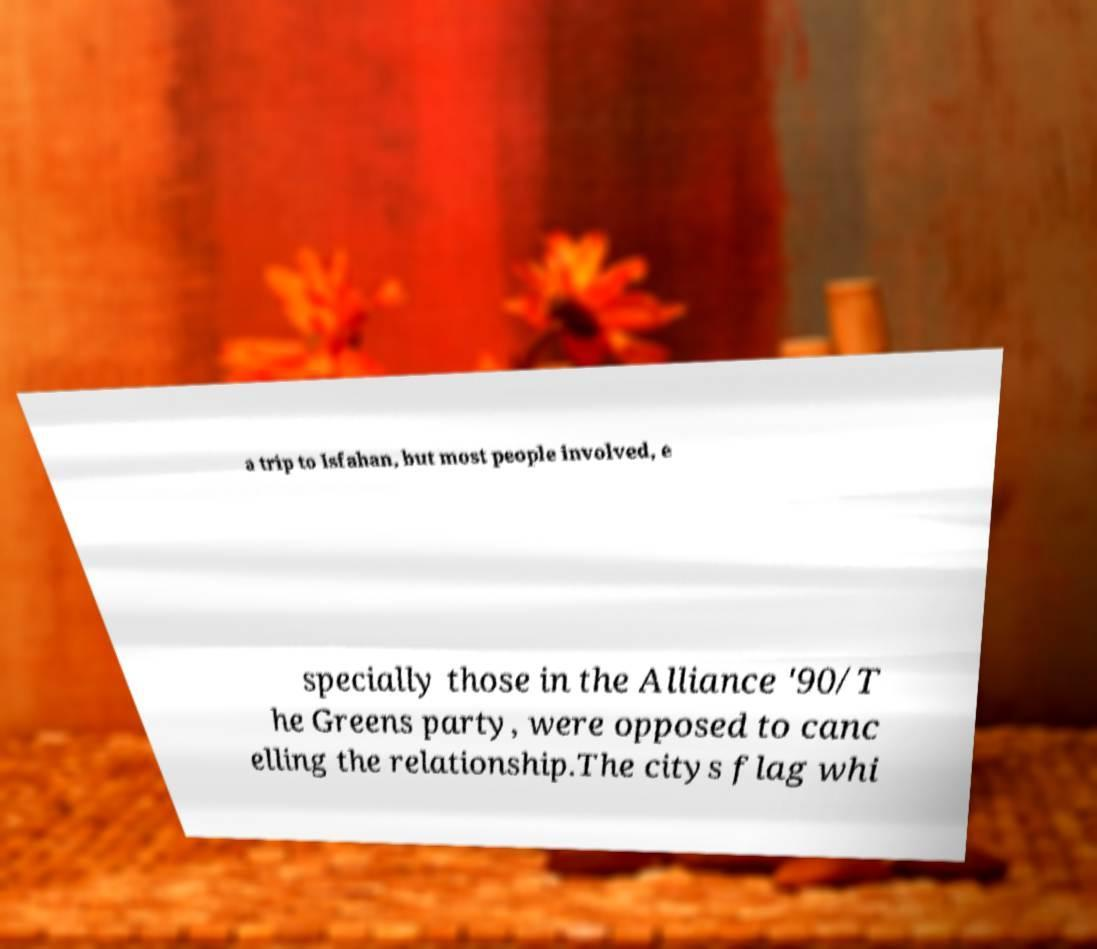Could you assist in decoding the text presented in this image and type it out clearly? a trip to Isfahan, but most people involved, e specially those in the Alliance '90/T he Greens party, were opposed to canc elling the relationship.The citys flag whi 